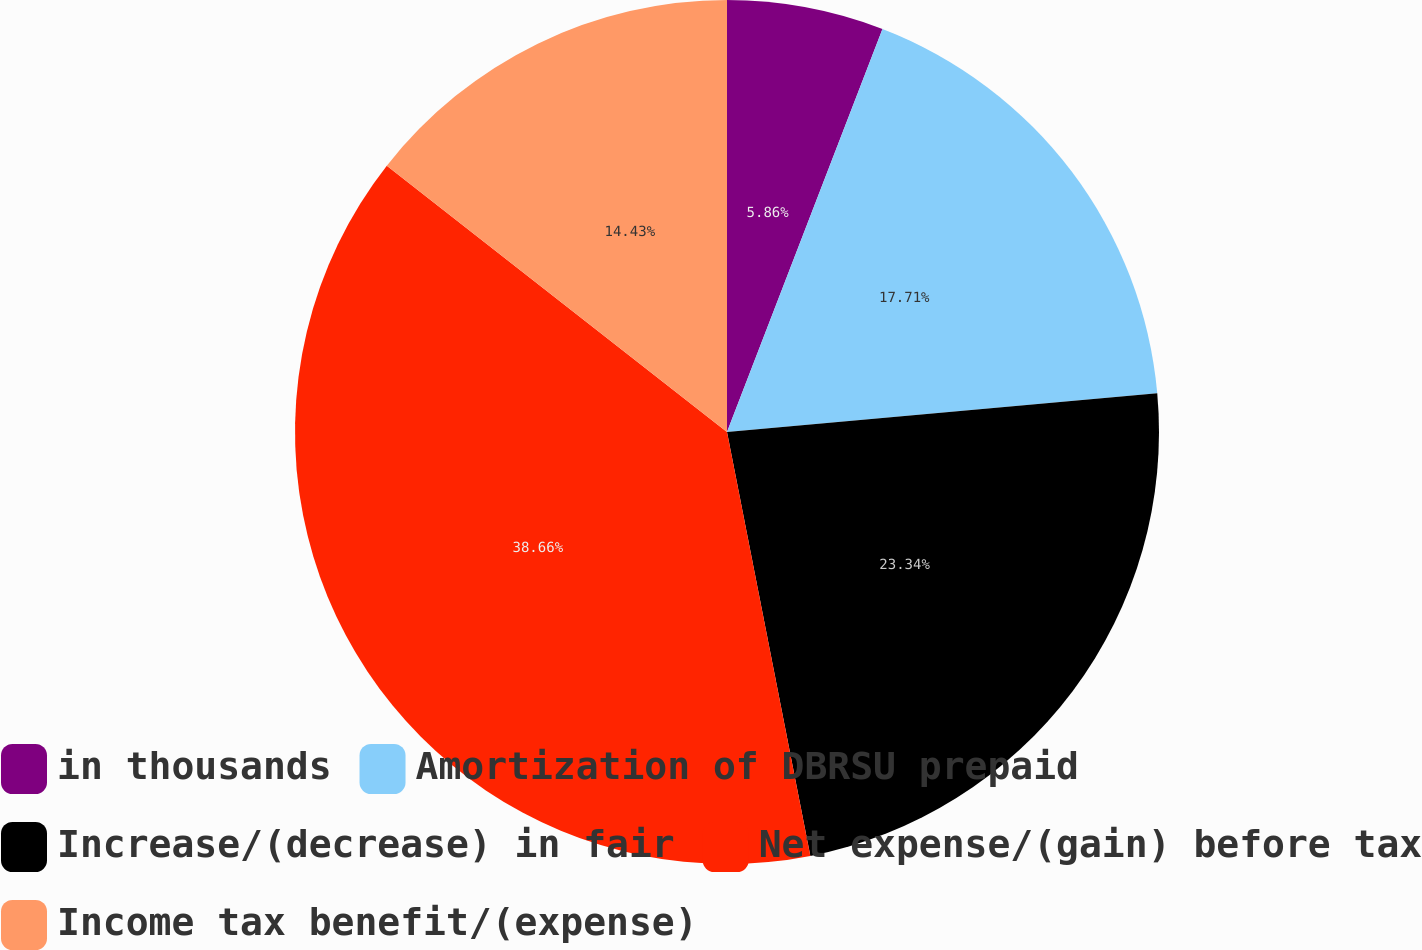Convert chart to OTSL. <chart><loc_0><loc_0><loc_500><loc_500><pie_chart><fcel>in thousands<fcel>Amortization of DBRSU prepaid<fcel>Increase/(decrease) in fair<fcel>Net expense/(gain) before tax<fcel>Income tax benefit/(expense)<nl><fcel>5.86%<fcel>17.71%<fcel>23.34%<fcel>38.66%<fcel>14.43%<nl></chart> 